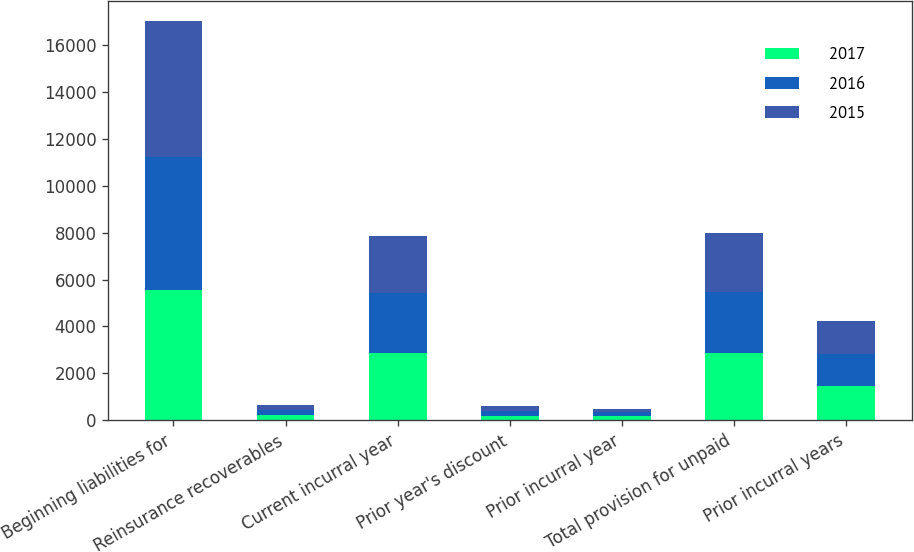Convert chart. <chart><loc_0><loc_0><loc_500><loc_500><stacked_bar_chart><ecel><fcel>Beginning liabilities for<fcel>Reinsurance recoverables<fcel>Current incurral year<fcel>Prior year's discount<fcel>Prior incurral year<fcel>Total provision for unpaid<fcel>Prior incurral years<nl><fcel>2017<fcel>5564<fcel>208<fcel>2868<fcel>202<fcel>185<fcel>2885<fcel>1451<nl><fcel>2016<fcel>5671<fcel>218<fcel>2562<fcel>202<fcel>162<fcel>2602<fcel>1382<nl><fcel>2015<fcel>5804<fcel>209<fcel>2447<fcel>214<fcel>146<fcel>2515<fcel>1391<nl></chart> 